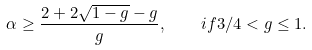Convert formula to latex. <formula><loc_0><loc_0><loc_500><loc_500>\alpha \geq \frac { 2 + 2 \sqrt { 1 - g } - g } { g } , \quad i f 3 / 4 < g \leq 1 .</formula> 